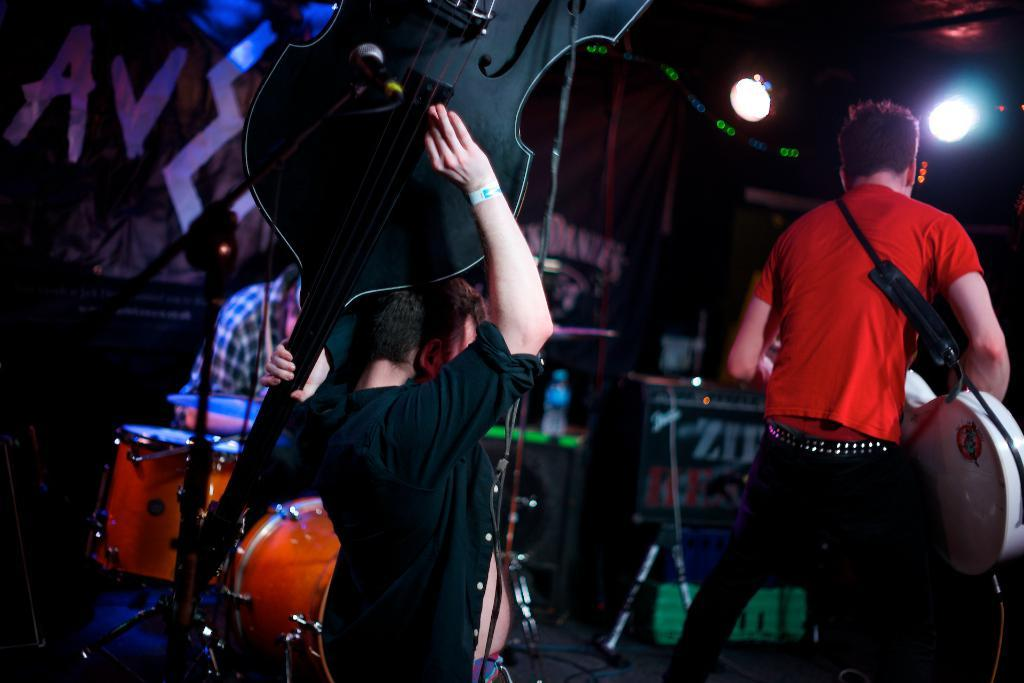How many people are in the image? There are three persons in the image. What are the three persons doing in the image? The three persons are playing musical instruments. What type of coil can be seen in the image? There is no coil present in the image. What kind of border surrounds the image? The image does not show a border; it only shows the three persons playing musical instruments. 